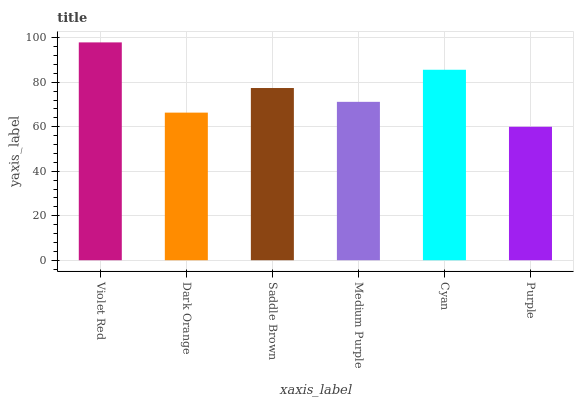Is Purple the minimum?
Answer yes or no. Yes. Is Violet Red the maximum?
Answer yes or no. Yes. Is Dark Orange the minimum?
Answer yes or no. No. Is Dark Orange the maximum?
Answer yes or no. No. Is Violet Red greater than Dark Orange?
Answer yes or no. Yes. Is Dark Orange less than Violet Red?
Answer yes or no. Yes. Is Dark Orange greater than Violet Red?
Answer yes or no. No. Is Violet Red less than Dark Orange?
Answer yes or no. No. Is Saddle Brown the high median?
Answer yes or no. Yes. Is Medium Purple the low median?
Answer yes or no. Yes. Is Purple the high median?
Answer yes or no. No. Is Purple the low median?
Answer yes or no. No. 